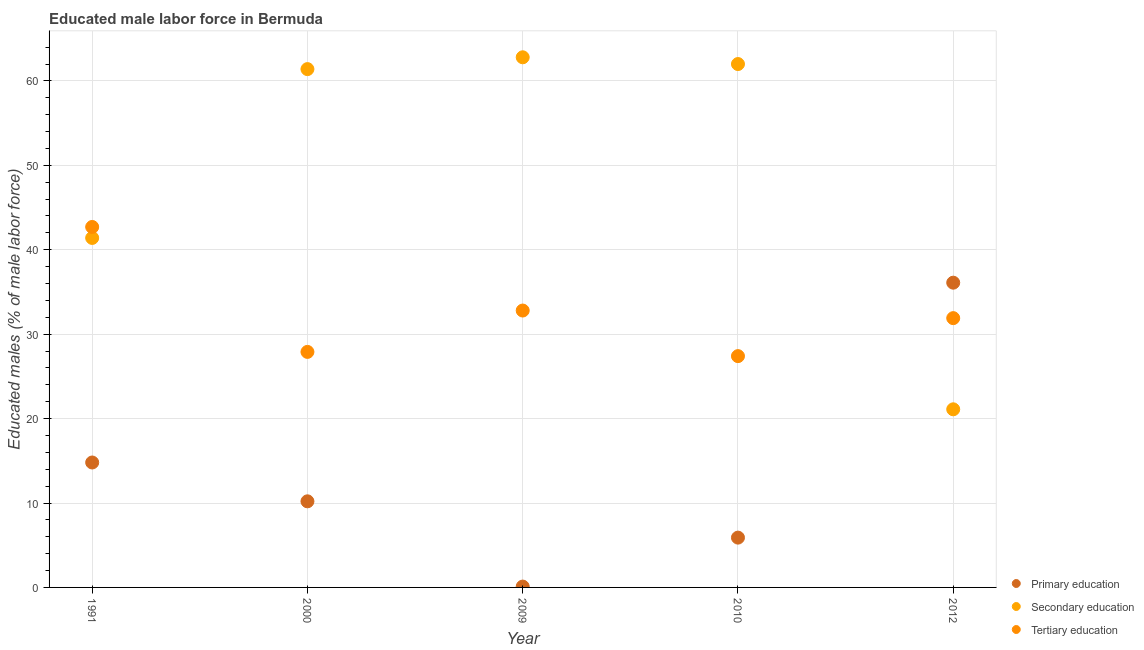How many different coloured dotlines are there?
Provide a short and direct response. 3. What is the percentage of male labor force who received primary education in 2010?
Provide a succinct answer. 5.9. Across all years, what is the maximum percentage of male labor force who received primary education?
Offer a terse response. 36.1. Across all years, what is the minimum percentage of male labor force who received primary education?
Keep it short and to the point. 0.1. In which year was the percentage of male labor force who received tertiary education maximum?
Offer a terse response. 1991. What is the total percentage of male labor force who received primary education in the graph?
Provide a succinct answer. 67.1. What is the difference between the percentage of male labor force who received tertiary education in 2009 and that in 2010?
Provide a succinct answer. 5.4. What is the difference between the percentage of male labor force who received secondary education in 2010 and the percentage of male labor force who received primary education in 2009?
Keep it short and to the point. 61.9. What is the average percentage of male labor force who received primary education per year?
Give a very brief answer. 13.42. In the year 1991, what is the difference between the percentage of male labor force who received primary education and percentage of male labor force who received secondary education?
Offer a very short reply. -26.6. In how many years, is the percentage of male labor force who received primary education greater than 18 %?
Your response must be concise. 1. What is the ratio of the percentage of male labor force who received tertiary education in 2009 to that in 2012?
Offer a very short reply. 1.03. Is the percentage of male labor force who received tertiary education in 1991 less than that in 2010?
Provide a succinct answer. No. What is the difference between the highest and the second highest percentage of male labor force who received primary education?
Keep it short and to the point. 21.3. What is the difference between the highest and the lowest percentage of male labor force who received tertiary education?
Your answer should be compact. 15.3. In how many years, is the percentage of male labor force who received secondary education greater than the average percentage of male labor force who received secondary education taken over all years?
Ensure brevity in your answer.  3. Is the percentage of male labor force who received primary education strictly greater than the percentage of male labor force who received tertiary education over the years?
Ensure brevity in your answer.  No. Is the percentage of male labor force who received secondary education strictly less than the percentage of male labor force who received primary education over the years?
Provide a short and direct response. No. How many years are there in the graph?
Ensure brevity in your answer.  5. Are the values on the major ticks of Y-axis written in scientific E-notation?
Your response must be concise. No. Does the graph contain grids?
Make the answer very short. Yes. Where does the legend appear in the graph?
Provide a short and direct response. Bottom right. How many legend labels are there?
Your answer should be very brief. 3. How are the legend labels stacked?
Your response must be concise. Vertical. What is the title of the graph?
Provide a succinct answer. Educated male labor force in Bermuda. What is the label or title of the X-axis?
Your answer should be compact. Year. What is the label or title of the Y-axis?
Ensure brevity in your answer.  Educated males (% of male labor force). What is the Educated males (% of male labor force) of Primary education in 1991?
Your answer should be very brief. 14.8. What is the Educated males (% of male labor force) of Secondary education in 1991?
Provide a succinct answer. 41.4. What is the Educated males (% of male labor force) of Tertiary education in 1991?
Give a very brief answer. 42.7. What is the Educated males (% of male labor force) in Primary education in 2000?
Your answer should be compact. 10.2. What is the Educated males (% of male labor force) in Secondary education in 2000?
Ensure brevity in your answer.  61.4. What is the Educated males (% of male labor force) of Tertiary education in 2000?
Provide a succinct answer. 27.9. What is the Educated males (% of male labor force) of Primary education in 2009?
Provide a succinct answer. 0.1. What is the Educated males (% of male labor force) of Secondary education in 2009?
Make the answer very short. 62.8. What is the Educated males (% of male labor force) of Tertiary education in 2009?
Provide a succinct answer. 32.8. What is the Educated males (% of male labor force) of Primary education in 2010?
Your answer should be very brief. 5.9. What is the Educated males (% of male labor force) in Tertiary education in 2010?
Make the answer very short. 27.4. What is the Educated males (% of male labor force) in Primary education in 2012?
Keep it short and to the point. 36.1. What is the Educated males (% of male labor force) of Secondary education in 2012?
Provide a succinct answer. 21.1. What is the Educated males (% of male labor force) of Tertiary education in 2012?
Offer a very short reply. 31.9. Across all years, what is the maximum Educated males (% of male labor force) in Primary education?
Your answer should be very brief. 36.1. Across all years, what is the maximum Educated males (% of male labor force) of Secondary education?
Provide a succinct answer. 62.8. Across all years, what is the maximum Educated males (% of male labor force) in Tertiary education?
Give a very brief answer. 42.7. Across all years, what is the minimum Educated males (% of male labor force) in Primary education?
Your answer should be compact. 0.1. Across all years, what is the minimum Educated males (% of male labor force) in Secondary education?
Keep it short and to the point. 21.1. Across all years, what is the minimum Educated males (% of male labor force) of Tertiary education?
Offer a terse response. 27.4. What is the total Educated males (% of male labor force) of Primary education in the graph?
Your answer should be very brief. 67.1. What is the total Educated males (% of male labor force) in Secondary education in the graph?
Give a very brief answer. 248.7. What is the total Educated males (% of male labor force) of Tertiary education in the graph?
Your response must be concise. 162.7. What is the difference between the Educated males (% of male labor force) of Secondary education in 1991 and that in 2000?
Ensure brevity in your answer.  -20. What is the difference between the Educated males (% of male labor force) in Primary education in 1991 and that in 2009?
Provide a succinct answer. 14.7. What is the difference between the Educated males (% of male labor force) of Secondary education in 1991 and that in 2009?
Ensure brevity in your answer.  -21.4. What is the difference between the Educated males (% of male labor force) of Tertiary education in 1991 and that in 2009?
Offer a terse response. 9.9. What is the difference between the Educated males (% of male labor force) in Secondary education in 1991 and that in 2010?
Make the answer very short. -20.6. What is the difference between the Educated males (% of male labor force) of Tertiary education in 1991 and that in 2010?
Give a very brief answer. 15.3. What is the difference between the Educated males (% of male labor force) in Primary education in 1991 and that in 2012?
Your answer should be compact. -21.3. What is the difference between the Educated males (% of male labor force) in Secondary education in 1991 and that in 2012?
Make the answer very short. 20.3. What is the difference between the Educated males (% of male labor force) of Tertiary education in 1991 and that in 2012?
Offer a very short reply. 10.8. What is the difference between the Educated males (% of male labor force) of Secondary education in 2000 and that in 2009?
Provide a succinct answer. -1.4. What is the difference between the Educated males (% of male labor force) of Primary education in 2000 and that in 2010?
Ensure brevity in your answer.  4.3. What is the difference between the Educated males (% of male labor force) of Secondary education in 2000 and that in 2010?
Your answer should be compact. -0.6. What is the difference between the Educated males (% of male labor force) of Primary education in 2000 and that in 2012?
Offer a terse response. -25.9. What is the difference between the Educated males (% of male labor force) of Secondary education in 2000 and that in 2012?
Offer a very short reply. 40.3. What is the difference between the Educated males (% of male labor force) in Primary education in 2009 and that in 2010?
Your answer should be very brief. -5.8. What is the difference between the Educated males (% of male labor force) of Primary education in 2009 and that in 2012?
Give a very brief answer. -36. What is the difference between the Educated males (% of male labor force) of Secondary education in 2009 and that in 2012?
Offer a very short reply. 41.7. What is the difference between the Educated males (% of male labor force) in Tertiary education in 2009 and that in 2012?
Offer a terse response. 0.9. What is the difference between the Educated males (% of male labor force) of Primary education in 2010 and that in 2012?
Ensure brevity in your answer.  -30.2. What is the difference between the Educated males (% of male labor force) in Secondary education in 2010 and that in 2012?
Provide a short and direct response. 40.9. What is the difference between the Educated males (% of male labor force) of Tertiary education in 2010 and that in 2012?
Provide a succinct answer. -4.5. What is the difference between the Educated males (% of male labor force) of Primary education in 1991 and the Educated males (% of male labor force) of Secondary education in 2000?
Your answer should be very brief. -46.6. What is the difference between the Educated males (% of male labor force) in Primary education in 1991 and the Educated males (% of male labor force) in Tertiary education in 2000?
Keep it short and to the point. -13.1. What is the difference between the Educated males (% of male labor force) in Secondary education in 1991 and the Educated males (% of male labor force) in Tertiary education in 2000?
Your response must be concise. 13.5. What is the difference between the Educated males (% of male labor force) in Primary education in 1991 and the Educated males (% of male labor force) in Secondary education in 2009?
Your answer should be compact. -48. What is the difference between the Educated males (% of male labor force) in Primary education in 1991 and the Educated males (% of male labor force) in Secondary education in 2010?
Make the answer very short. -47.2. What is the difference between the Educated males (% of male labor force) in Primary education in 1991 and the Educated males (% of male labor force) in Secondary education in 2012?
Ensure brevity in your answer.  -6.3. What is the difference between the Educated males (% of male labor force) of Primary education in 1991 and the Educated males (% of male labor force) of Tertiary education in 2012?
Make the answer very short. -17.1. What is the difference between the Educated males (% of male labor force) in Secondary education in 1991 and the Educated males (% of male labor force) in Tertiary education in 2012?
Your answer should be very brief. 9.5. What is the difference between the Educated males (% of male labor force) of Primary education in 2000 and the Educated males (% of male labor force) of Secondary education in 2009?
Provide a succinct answer. -52.6. What is the difference between the Educated males (% of male labor force) in Primary education in 2000 and the Educated males (% of male labor force) in Tertiary education in 2009?
Your response must be concise. -22.6. What is the difference between the Educated males (% of male labor force) in Secondary education in 2000 and the Educated males (% of male labor force) in Tertiary education in 2009?
Ensure brevity in your answer.  28.6. What is the difference between the Educated males (% of male labor force) of Primary education in 2000 and the Educated males (% of male labor force) of Secondary education in 2010?
Ensure brevity in your answer.  -51.8. What is the difference between the Educated males (% of male labor force) of Primary education in 2000 and the Educated males (% of male labor force) of Tertiary education in 2010?
Provide a short and direct response. -17.2. What is the difference between the Educated males (% of male labor force) in Secondary education in 2000 and the Educated males (% of male labor force) in Tertiary education in 2010?
Keep it short and to the point. 34. What is the difference between the Educated males (% of male labor force) in Primary education in 2000 and the Educated males (% of male labor force) in Tertiary education in 2012?
Keep it short and to the point. -21.7. What is the difference between the Educated males (% of male labor force) in Secondary education in 2000 and the Educated males (% of male labor force) in Tertiary education in 2012?
Offer a very short reply. 29.5. What is the difference between the Educated males (% of male labor force) of Primary education in 2009 and the Educated males (% of male labor force) of Secondary education in 2010?
Keep it short and to the point. -61.9. What is the difference between the Educated males (% of male labor force) of Primary education in 2009 and the Educated males (% of male labor force) of Tertiary education in 2010?
Ensure brevity in your answer.  -27.3. What is the difference between the Educated males (% of male labor force) of Secondary education in 2009 and the Educated males (% of male labor force) of Tertiary education in 2010?
Offer a very short reply. 35.4. What is the difference between the Educated males (% of male labor force) of Primary education in 2009 and the Educated males (% of male labor force) of Secondary education in 2012?
Your response must be concise. -21. What is the difference between the Educated males (% of male labor force) in Primary education in 2009 and the Educated males (% of male labor force) in Tertiary education in 2012?
Make the answer very short. -31.8. What is the difference between the Educated males (% of male labor force) of Secondary education in 2009 and the Educated males (% of male labor force) of Tertiary education in 2012?
Provide a succinct answer. 30.9. What is the difference between the Educated males (% of male labor force) of Primary education in 2010 and the Educated males (% of male labor force) of Secondary education in 2012?
Your response must be concise. -15.2. What is the difference between the Educated males (% of male labor force) of Primary education in 2010 and the Educated males (% of male labor force) of Tertiary education in 2012?
Your answer should be very brief. -26. What is the difference between the Educated males (% of male labor force) of Secondary education in 2010 and the Educated males (% of male labor force) of Tertiary education in 2012?
Provide a succinct answer. 30.1. What is the average Educated males (% of male labor force) of Primary education per year?
Provide a succinct answer. 13.42. What is the average Educated males (% of male labor force) in Secondary education per year?
Ensure brevity in your answer.  49.74. What is the average Educated males (% of male labor force) in Tertiary education per year?
Your answer should be compact. 32.54. In the year 1991, what is the difference between the Educated males (% of male labor force) in Primary education and Educated males (% of male labor force) in Secondary education?
Your answer should be compact. -26.6. In the year 1991, what is the difference between the Educated males (% of male labor force) of Primary education and Educated males (% of male labor force) of Tertiary education?
Ensure brevity in your answer.  -27.9. In the year 2000, what is the difference between the Educated males (% of male labor force) of Primary education and Educated males (% of male labor force) of Secondary education?
Provide a succinct answer. -51.2. In the year 2000, what is the difference between the Educated males (% of male labor force) in Primary education and Educated males (% of male labor force) in Tertiary education?
Provide a short and direct response. -17.7. In the year 2000, what is the difference between the Educated males (% of male labor force) of Secondary education and Educated males (% of male labor force) of Tertiary education?
Offer a terse response. 33.5. In the year 2009, what is the difference between the Educated males (% of male labor force) of Primary education and Educated males (% of male labor force) of Secondary education?
Provide a short and direct response. -62.7. In the year 2009, what is the difference between the Educated males (% of male labor force) in Primary education and Educated males (% of male labor force) in Tertiary education?
Your answer should be compact. -32.7. In the year 2010, what is the difference between the Educated males (% of male labor force) of Primary education and Educated males (% of male labor force) of Secondary education?
Give a very brief answer. -56.1. In the year 2010, what is the difference between the Educated males (% of male labor force) in Primary education and Educated males (% of male labor force) in Tertiary education?
Provide a succinct answer. -21.5. In the year 2010, what is the difference between the Educated males (% of male labor force) of Secondary education and Educated males (% of male labor force) of Tertiary education?
Give a very brief answer. 34.6. In the year 2012, what is the difference between the Educated males (% of male labor force) in Primary education and Educated males (% of male labor force) in Secondary education?
Provide a succinct answer. 15. What is the ratio of the Educated males (% of male labor force) of Primary education in 1991 to that in 2000?
Provide a succinct answer. 1.45. What is the ratio of the Educated males (% of male labor force) in Secondary education in 1991 to that in 2000?
Provide a short and direct response. 0.67. What is the ratio of the Educated males (% of male labor force) in Tertiary education in 1991 to that in 2000?
Give a very brief answer. 1.53. What is the ratio of the Educated males (% of male labor force) in Primary education in 1991 to that in 2009?
Offer a very short reply. 148. What is the ratio of the Educated males (% of male labor force) of Secondary education in 1991 to that in 2009?
Your response must be concise. 0.66. What is the ratio of the Educated males (% of male labor force) of Tertiary education in 1991 to that in 2009?
Keep it short and to the point. 1.3. What is the ratio of the Educated males (% of male labor force) in Primary education in 1991 to that in 2010?
Keep it short and to the point. 2.51. What is the ratio of the Educated males (% of male labor force) in Secondary education in 1991 to that in 2010?
Give a very brief answer. 0.67. What is the ratio of the Educated males (% of male labor force) of Tertiary education in 1991 to that in 2010?
Keep it short and to the point. 1.56. What is the ratio of the Educated males (% of male labor force) of Primary education in 1991 to that in 2012?
Your answer should be very brief. 0.41. What is the ratio of the Educated males (% of male labor force) of Secondary education in 1991 to that in 2012?
Your answer should be very brief. 1.96. What is the ratio of the Educated males (% of male labor force) of Tertiary education in 1991 to that in 2012?
Provide a short and direct response. 1.34. What is the ratio of the Educated males (% of male labor force) of Primary education in 2000 to that in 2009?
Give a very brief answer. 102. What is the ratio of the Educated males (% of male labor force) of Secondary education in 2000 to that in 2009?
Offer a terse response. 0.98. What is the ratio of the Educated males (% of male labor force) of Tertiary education in 2000 to that in 2009?
Ensure brevity in your answer.  0.85. What is the ratio of the Educated males (% of male labor force) of Primary education in 2000 to that in 2010?
Ensure brevity in your answer.  1.73. What is the ratio of the Educated males (% of male labor force) in Secondary education in 2000 to that in 2010?
Keep it short and to the point. 0.99. What is the ratio of the Educated males (% of male labor force) in Tertiary education in 2000 to that in 2010?
Provide a succinct answer. 1.02. What is the ratio of the Educated males (% of male labor force) of Primary education in 2000 to that in 2012?
Provide a succinct answer. 0.28. What is the ratio of the Educated males (% of male labor force) in Secondary education in 2000 to that in 2012?
Ensure brevity in your answer.  2.91. What is the ratio of the Educated males (% of male labor force) in Tertiary education in 2000 to that in 2012?
Provide a short and direct response. 0.87. What is the ratio of the Educated males (% of male labor force) in Primary education in 2009 to that in 2010?
Make the answer very short. 0.02. What is the ratio of the Educated males (% of male labor force) in Secondary education in 2009 to that in 2010?
Provide a short and direct response. 1.01. What is the ratio of the Educated males (% of male labor force) in Tertiary education in 2009 to that in 2010?
Your answer should be very brief. 1.2. What is the ratio of the Educated males (% of male labor force) in Primary education in 2009 to that in 2012?
Keep it short and to the point. 0. What is the ratio of the Educated males (% of male labor force) in Secondary education in 2009 to that in 2012?
Offer a terse response. 2.98. What is the ratio of the Educated males (% of male labor force) in Tertiary education in 2009 to that in 2012?
Give a very brief answer. 1.03. What is the ratio of the Educated males (% of male labor force) of Primary education in 2010 to that in 2012?
Offer a terse response. 0.16. What is the ratio of the Educated males (% of male labor force) in Secondary education in 2010 to that in 2012?
Provide a succinct answer. 2.94. What is the ratio of the Educated males (% of male labor force) in Tertiary education in 2010 to that in 2012?
Offer a very short reply. 0.86. What is the difference between the highest and the second highest Educated males (% of male labor force) in Primary education?
Offer a very short reply. 21.3. What is the difference between the highest and the second highest Educated males (% of male labor force) of Secondary education?
Your answer should be very brief. 0.8. What is the difference between the highest and the lowest Educated males (% of male labor force) of Secondary education?
Offer a terse response. 41.7. 